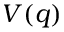Convert formula to latex. <formula><loc_0><loc_0><loc_500><loc_500>V ( q )</formula> 